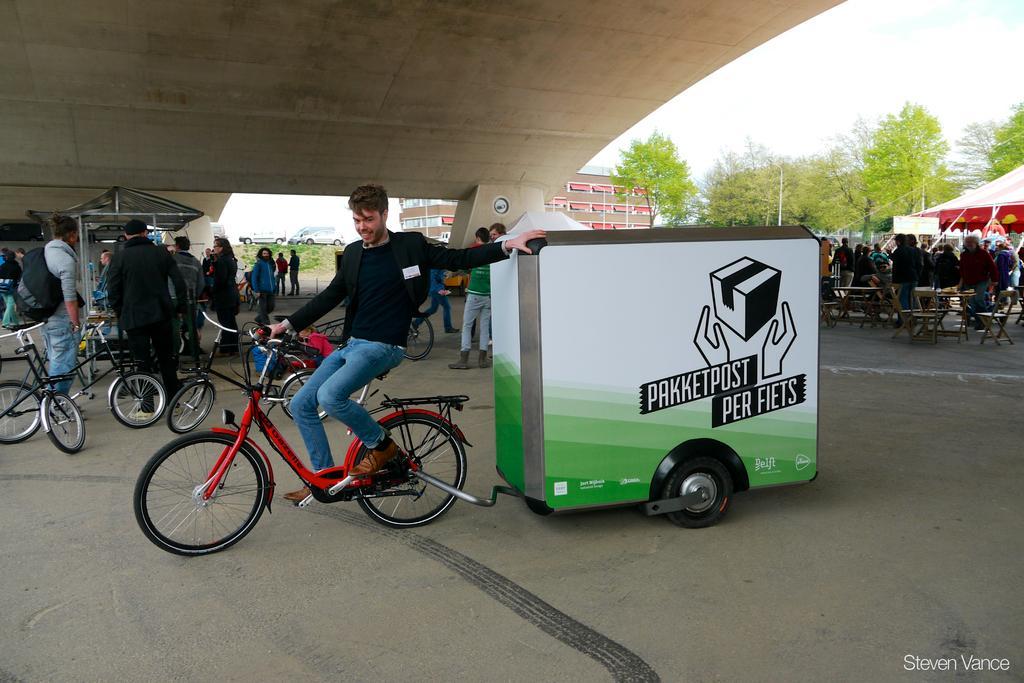How would you summarize this image in a sentence or two? In this picture there are group of people. In the foreground there is a person sitting on the bicycle and he is holding the trolley. On the left side of the image there are bicycles and there are people standing. On the right side of the image there are group of people standing at the tables and there are tables and chairs under the tent. At the back there is a building and there are trees, poles and vehicles. At the top there is sky. At the bottom there is a road. 